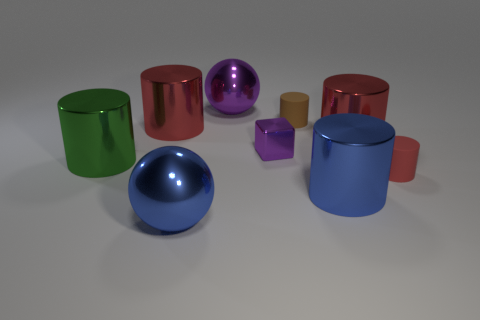Are there any tiny balls of the same color as the cube?
Your answer should be very brief. No. There is a sphere that is in front of the big purple metallic object; is it the same color as the big shiny ball behind the blue metallic cylinder?
Your answer should be very brief. No. What material is the sphere behind the purple block?
Provide a short and direct response. Metal. There is a tiny block that is the same material as the green object; what color is it?
Your answer should be very brief. Purple. What number of brown things are the same size as the blue metal sphere?
Your response must be concise. 0. Does the ball to the right of the blue metal sphere have the same size as the blue cylinder?
Your response must be concise. Yes. There is a object that is both left of the blue sphere and on the right side of the green cylinder; what is its shape?
Your response must be concise. Cylinder. Are there any green shiny objects on the left side of the green cylinder?
Your answer should be very brief. No. Is there any other thing that has the same shape as the small metal object?
Your response must be concise. No. Do the brown rubber object and the large purple object have the same shape?
Provide a succinct answer. No. 